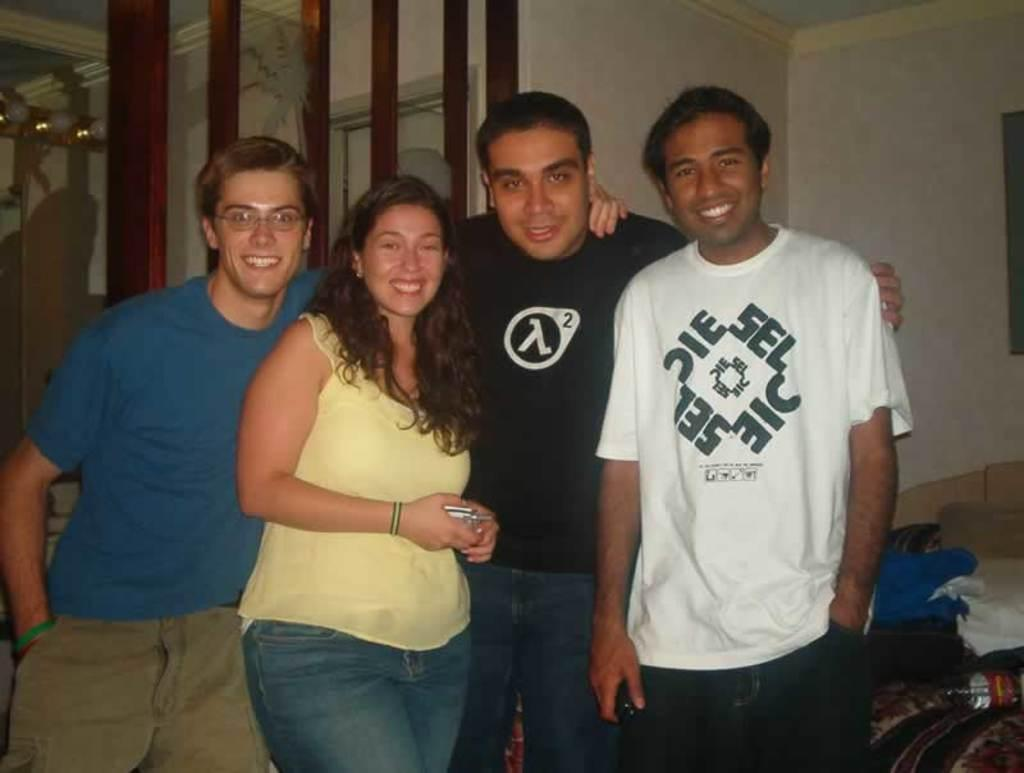How many people are in the image? There are four people in the image: three men and one woman. What are the people in the image doing? The people are posing for a photograph. What can be seen in the background of the image? There is a wall and wooden frames in the background of the image. What type of cannon is visible in the image? A: There is no cannon present in the image. Can you describe the camera used to take the photograph in the image? The image does not show the camera used to take the photograph. 